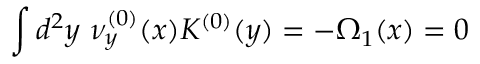<formula> <loc_0><loc_0><loc_500><loc_500>\int d ^ { 2 } y \nu _ { y } ^ { ( 0 ) } ( x ) K ^ { ( 0 ) } ( y ) = - \Omega _ { 1 } ( x ) = 0</formula> 